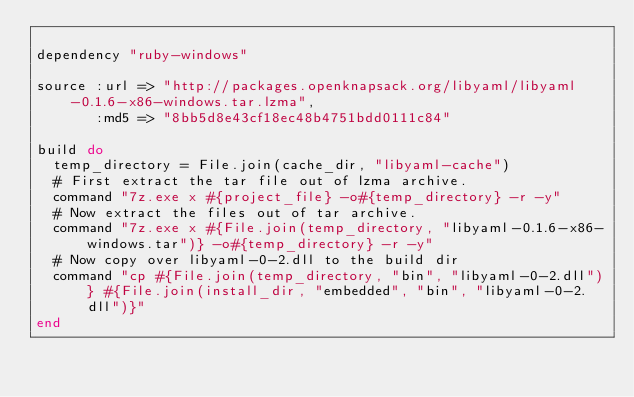<code> <loc_0><loc_0><loc_500><loc_500><_Ruby_>
dependency "ruby-windows"

source :url => "http://packages.openknapsack.org/libyaml/libyaml-0.1.6-x86-windows.tar.lzma",
       :md5 => "8bb5d8e43cf18ec48b4751bdd0111c84"

build do
  temp_directory = File.join(cache_dir, "libyaml-cache")
  # First extract the tar file out of lzma archive.
  command "7z.exe x #{project_file} -o#{temp_directory} -r -y"
  # Now extract the files out of tar archive.
  command "7z.exe x #{File.join(temp_directory, "libyaml-0.1.6-x86-windows.tar")} -o#{temp_directory} -r -y"
  # Now copy over libyaml-0-2.dll to the build dir
  command "cp #{File.join(temp_directory, "bin", "libyaml-0-2.dll")} #{File.join(install_dir, "embedded", "bin", "libyaml-0-2.dll")}"
end
</code> 